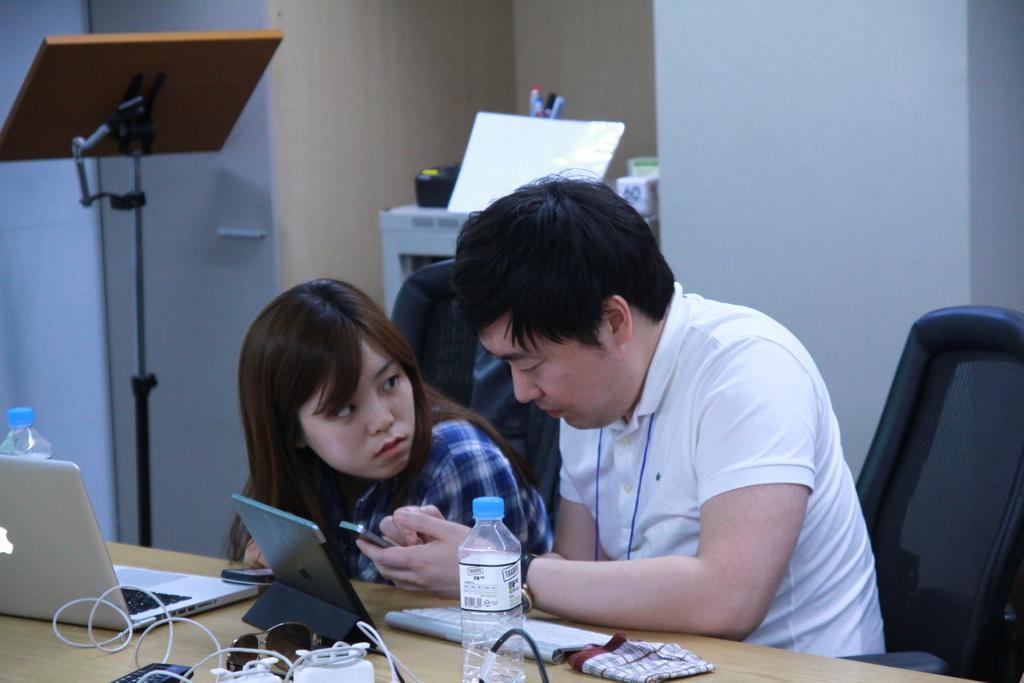Could you give a brief overview of what you see in this image? A person wearing a white dress is holding a mobile. Beside him another lady is sitting. And there is a chair. In front of them there is a table. On the table there are laptop, bottles, tab, towel, wires, goggle and many other items. In the background there are wall, a stand a table. On the table there are pens and many other items. 